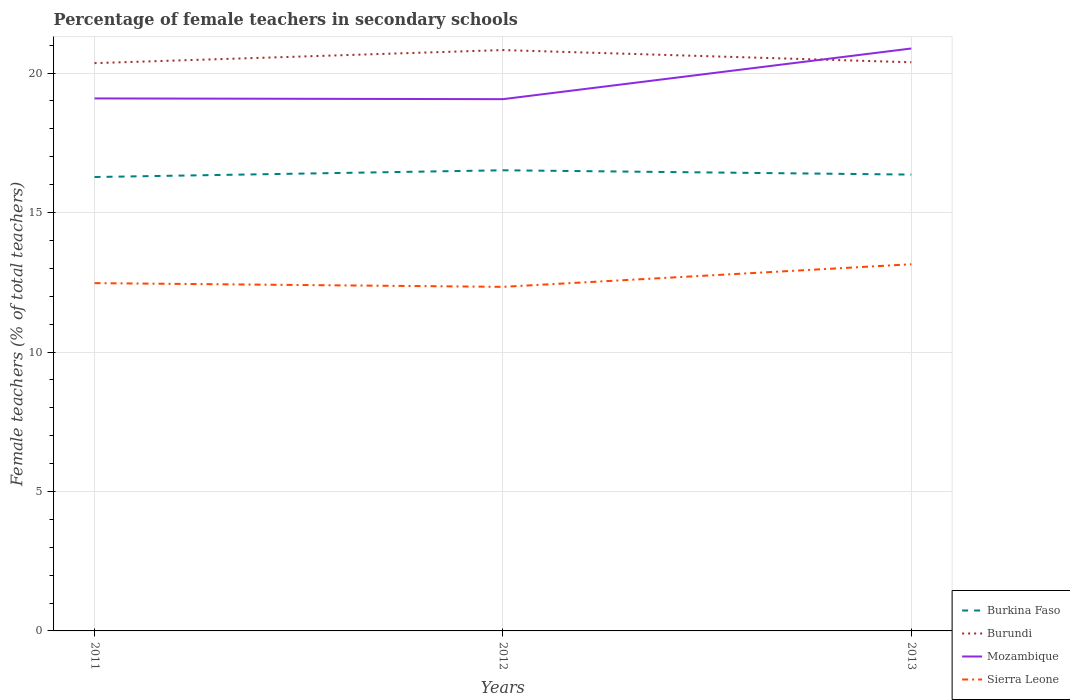How many different coloured lines are there?
Offer a very short reply. 4. Across all years, what is the maximum percentage of female teachers in Burundi?
Provide a succinct answer. 20.36. What is the total percentage of female teachers in Mozambique in the graph?
Offer a terse response. 0.03. What is the difference between the highest and the second highest percentage of female teachers in Sierra Leone?
Your answer should be compact. 0.81. Is the percentage of female teachers in Burkina Faso strictly greater than the percentage of female teachers in Sierra Leone over the years?
Keep it short and to the point. No. What is the difference between two consecutive major ticks on the Y-axis?
Your answer should be compact. 5. Are the values on the major ticks of Y-axis written in scientific E-notation?
Your answer should be compact. No. Does the graph contain any zero values?
Provide a short and direct response. No. What is the title of the graph?
Ensure brevity in your answer.  Percentage of female teachers in secondary schools. What is the label or title of the X-axis?
Offer a very short reply. Years. What is the label or title of the Y-axis?
Offer a very short reply. Female teachers (% of total teachers). What is the Female teachers (% of total teachers) of Burkina Faso in 2011?
Your response must be concise. 16.27. What is the Female teachers (% of total teachers) of Burundi in 2011?
Offer a very short reply. 20.36. What is the Female teachers (% of total teachers) in Mozambique in 2011?
Offer a terse response. 19.09. What is the Female teachers (% of total teachers) in Sierra Leone in 2011?
Offer a very short reply. 12.47. What is the Female teachers (% of total teachers) in Burkina Faso in 2012?
Provide a short and direct response. 16.52. What is the Female teachers (% of total teachers) in Burundi in 2012?
Offer a very short reply. 20.83. What is the Female teachers (% of total teachers) in Mozambique in 2012?
Keep it short and to the point. 19.07. What is the Female teachers (% of total teachers) of Sierra Leone in 2012?
Provide a succinct answer. 12.34. What is the Female teachers (% of total teachers) of Burkina Faso in 2013?
Your answer should be very brief. 16.36. What is the Female teachers (% of total teachers) in Burundi in 2013?
Give a very brief answer. 20.39. What is the Female teachers (% of total teachers) in Mozambique in 2013?
Ensure brevity in your answer.  20.88. What is the Female teachers (% of total teachers) of Sierra Leone in 2013?
Make the answer very short. 13.15. Across all years, what is the maximum Female teachers (% of total teachers) of Burkina Faso?
Provide a short and direct response. 16.52. Across all years, what is the maximum Female teachers (% of total teachers) in Burundi?
Your response must be concise. 20.83. Across all years, what is the maximum Female teachers (% of total teachers) of Mozambique?
Your answer should be compact. 20.88. Across all years, what is the maximum Female teachers (% of total teachers) of Sierra Leone?
Make the answer very short. 13.15. Across all years, what is the minimum Female teachers (% of total teachers) of Burkina Faso?
Your answer should be compact. 16.27. Across all years, what is the minimum Female teachers (% of total teachers) of Burundi?
Offer a very short reply. 20.36. Across all years, what is the minimum Female teachers (% of total teachers) in Mozambique?
Your answer should be compact. 19.07. Across all years, what is the minimum Female teachers (% of total teachers) of Sierra Leone?
Offer a terse response. 12.34. What is the total Female teachers (% of total teachers) in Burkina Faso in the graph?
Make the answer very short. 49.15. What is the total Female teachers (% of total teachers) of Burundi in the graph?
Provide a succinct answer. 61.57. What is the total Female teachers (% of total teachers) in Mozambique in the graph?
Make the answer very short. 59.04. What is the total Female teachers (% of total teachers) of Sierra Leone in the graph?
Provide a succinct answer. 37.95. What is the difference between the Female teachers (% of total teachers) of Burkina Faso in 2011 and that in 2012?
Your response must be concise. -0.24. What is the difference between the Female teachers (% of total teachers) of Burundi in 2011 and that in 2012?
Give a very brief answer. -0.47. What is the difference between the Female teachers (% of total teachers) in Mozambique in 2011 and that in 2012?
Ensure brevity in your answer.  0.03. What is the difference between the Female teachers (% of total teachers) in Sierra Leone in 2011 and that in 2012?
Make the answer very short. 0.13. What is the difference between the Female teachers (% of total teachers) in Burkina Faso in 2011 and that in 2013?
Provide a succinct answer. -0.09. What is the difference between the Female teachers (% of total teachers) in Burundi in 2011 and that in 2013?
Your answer should be compact. -0.03. What is the difference between the Female teachers (% of total teachers) in Mozambique in 2011 and that in 2013?
Provide a short and direct response. -1.79. What is the difference between the Female teachers (% of total teachers) in Sierra Leone in 2011 and that in 2013?
Your response must be concise. -0.68. What is the difference between the Female teachers (% of total teachers) of Burkina Faso in 2012 and that in 2013?
Your answer should be very brief. 0.15. What is the difference between the Female teachers (% of total teachers) of Burundi in 2012 and that in 2013?
Provide a succinct answer. 0.44. What is the difference between the Female teachers (% of total teachers) of Mozambique in 2012 and that in 2013?
Give a very brief answer. -1.82. What is the difference between the Female teachers (% of total teachers) of Sierra Leone in 2012 and that in 2013?
Offer a very short reply. -0.81. What is the difference between the Female teachers (% of total teachers) in Burkina Faso in 2011 and the Female teachers (% of total teachers) in Burundi in 2012?
Your answer should be very brief. -4.55. What is the difference between the Female teachers (% of total teachers) of Burkina Faso in 2011 and the Female teachers (% of total teachers) of Mozambique in 2012?
Ensure brevity in your answer.  -2.79. What is the difference between the Female teachers (% of total teachers) of Burkina Faso in 2011 and the Female teachers (% of total teachers) of Sierra Leone in 2012?
Make the answer very short. 3.94. What is the difference between the Female teachers (% of total teachers) of Burundi in 2011 and the Female teachers (% of total teachers) of Mozambique in 2012?
Provide a succinct answer. 1.29. What is the difference between the Female teachers (% of total teachers) of Burundi in 2011 and the Female teachers (% of total teachers) of Sierra Leone in 2012?
Your answer should be very brief. 8.02. What is the difference between the Female teachers (% of total teachers) of Mozambique in 2011 and the Female teachers (% of total teachers) of Sierra Leone in 2012?
Ensure brevity in your answer.  6.76. What is the difference between the Female teachers (% of total teachers) in Burkina Faso in 2011 and the Female teachers (% of total teachers) in Burundi in 2013?
Your answer should be compact. -4.11. What is the difference between the Female teachers (% of total teachers) in Burkina Faso in 2011 and the Female teachers (% of total teachers) in Mozambique in 2013?
Your answer should be compact. -4.61. What is the difference between the Female teachers (% of total teachers) in Burkina Faso in 2011 and the Female teachers (% of total teachers) in Sierra Leone in 2013?
Provide a succinct answer. 3.13. What is the difference between the Female teachers (% of total teachers) in Burundi in 2011 and the Female teachers (% of total teachers) in Mozambique in 2013?
Your answer should be compact. -0.52. What is the difference between the Female teachers (% of total teachers) in Burundi in 2011 and the Female teachers (% of total teachers) in Sierra Leone in 2013?
Give a very brief answer. 7.21. What is the difference between the Female teachers (% of total teachers) in Mozambique in 2011 and the Female teachers (% of total teachers) in Sierra Leone in 2013?
Offer a terse response. 5.95. What is the difference between the Female teachers (% of total teachers) in Burkina Faso in 2012 and the Female teachers (% of total teachers) in Burundi in 2013?
Ensure brevity in your answer.  -3.87. What is the difference between the Female teachers (% of total teachers) in Burkina Faso in 2012 and the Female teachers (% of total teachers) in Mozambique in 2013?
Your answer should be very brief. -4.37. What is the difference between the Female teachers (% of total teachers) of Burkina Faso in 2012 and the Female teachers (% of total teachers) of Sierra Leone in 2013?
Provide a short and direct response. 3.37. What is the difference between the Female teachers (% of total teachers) of Burundi in 2012 and the Female teachers (% of total teachers) of Mozambique in 2013?
Your response must be concise. -0.06. What is the difference between the Female teachers (% of total teachers) of Burundi in 2012 and the Female teachers (% of total teachers) of Sierra Leone in 2013?
Offer a very short reply. 7.68. What is the difference between the Female teachers (% of total teachers) in Mozambique in 2012 and the Female teachers (% of total teachers) in Sierra Leone in 2013?
Your response must be concise. 5.92. What is the average Female teachers (% of total teachers) in Burkina Faso per year?
Offer a very short reply. 16.38. What is the average Female teachers (% of total teachers) in Burundi per year?
Ensure brevity in your answer.  20.52. What is the average Female teachers (% of total teachers) in Mozambique per year?
Your answer should be very brief. 19.68. What is the average Female teachers (% of total teachers) of Sierra Leone per year?
Offer a terse response. 12.65. In the year 2011, what is the difference between the Female teachers (% of total teachers) of Burkina Faso and Female teachers (% of total teachers) of Burundi?
Offer a very short reply. -4.08. In the year 2011, what is the difference between the Female teachers (% of total teachers) in Burkina Faso and Female teachers (% of total teachers) in Mozambique?
Provide a succinct answer. -2.82. In the year 2011, what is the difference between the Female teachers (% of total teachers) of Burkina Faso and Female teachers (% of total teachers) of Sierra Leone?
Ensure brevity in your answer.  3.8. In the year 2011, what is the difference between the Female teachers (% of total teachers) of Burundi and Female teachers (% of total teachers) of Mozambique?
Provide a short and direct response. 1.27. In the year 2011, what is the difference between the Female teachers (% of total teachers) in Burundi and Female teachers (% of total teachers) in Sierra Leone?
Keep it short and to the point. 7.89. In the year 2011, what is the difference between the Female teachers (% of total teachers) of Mozambique and Female teachers (% of total teachers) of Sierra Leone?
Give a very brief answer. 6.62. In the year 2012, what is the difference between the Female teachers (% of total teachers) in Burkina Faso and Female teachers (% of total teachers) in Burundi?
Your response must be concise. -4.31. In the year 2012, what is the difference between the Female teachers (% of total teachers) in Burkina Faso and Female teachers (% of total teachers) in Mozambique?
Ensure brevity in your answer.  -2.55. In the year 2012, what is the difference between the Female teachers (% of total teachers) of Burkina Faso and Female teachers (% of total teachers) of Sierra Leone?
Your response must be concise. 4.18. In the year 2012, what is the difference between the Female teachers (% of total teachers) of Burundi and Female teachers (% of total teachers) of Mozambique?
Give a very brief answer. 1.76. In the year 2012, what is the difference between the Female teachers (% of total teachers) in Burundi and Female teachers (% of total teachers) in Sierra Leone?
Your answer should be very brief. 8.49. In the year 2012, what is the difference between the Female teachers (% of total teachers) of Mozambique and Female teachers (% of total teachers) of Sierra Leone?
Offer a very short reply. 6.73. In the year 2013, what is the difference between the Female teachers (% of total teachers) in Burkina Faso and Female teachers (% of total teachers) in Burundi?
Offer a very short reply. -4.03. In the year 2013, what is the difference between the Female teachers (% of total teachers) of Burkina Faso and Female teachers (% of total teachers) of Mozambique?
Offer a terse response. -4.52. In the year 2013, what is the difference between the Female teachers (% of total teachers) of Burkina Faso and Female teachers (% of total teachers) of Sierra Leone?
Your answer should be compact. 3.22. In the year 2013, what is the difference between the Female teachers (% of total teachers) in Burundi and Female teachers (% of total teachers) in Mozambique?
Give a very brief answer. -0.49. In the year 2013, what is the difference between the Female teachers (% of total teachers) in Burundi and Female teachers (% of total teachers) in Sierra Leone?
Keep it short and to the point. 7.24. In the year 2013, what is the difference between the Female teachers (% of total teachers) in Mozambique and Female teachers (% of total teachers) in Sierra Leone?
Ensure brevity in your answer.  7.74. What is the ratio of the Female teachers (% of total teachers) in Burkina Faso in 2011 to that in 2012?
Provide a succinct answer. 0.99. What is the ratio of the Female teachers (% of total teachers) in Burundi in 2011 to that in 2012?
Give a very brief answer. 0.98. What is the ratio of the Female teachers (% of total teachers) of Mozambique in 2011 to that in 2012?
Keep it short and to the point. 1. What is the ratio of the Female teachers (% of total teachers) of Sierra Leone in 2011 to that in 2012?
Give a very brief answer. 1.01. What is the ratio of the Female teachers (% of total teachers) in Burkina Faso in 2011 to that in 2013?
Give a very brief answer. 0.99. What is the ratio of the Female teachers (% of total teachers) of Burundi in 2011 to that in 2013?
Provide a succinct answer. 1. What is the ratio of the Female teachers (% of total teachers) of Mozambique in 2011 to that in 2013?
Keep it short and to the point. 0.91. What is the ratio of the Female teachers (% of total teachers) in Sierra Leone in 2011 to that in 2013?
Your answer should be very brief. 0.95. What is the ratio of the Female teachers (% of total teachers) of Burkina Faso in 2012 to that in 2013?
Your answer should be compact. 1.01. What is the ratio of the Female teachers (% of total teachers) in Burundi in 2012 to that in 2013?
Ensure brevity in your answer.  1.02. What is the ratio of the Female teachers (% of total teachers) of Sierra Leone in 2012 to that in 2013?
Provide a succinct answer. 0.94. What is the difference between the highest and the second highest Female teachers (% of total teachers) of Burkina Faso?
Ensure brevity in your answer.  0.15. What is the difference between the highest and the second highest Female teachers (% of total teachers) in Burundi?
Provide a short and direct response. 0.44. What is the difference between the highest and the second highest Female teachers (% of total teachers) of Mozambique?
Offer a terse response. 1.79. What is the difference between the highest and the second highest Female teachers (% of total teachers) in Sierra Leone?
Provide a short and direct response. 0.68. What is the difference between the highest and the lowest Female teachers (% of total teachers) in Burkina Faso?
Your answer should be compact. 0.24. What is the difference between the highest and the lowest Female teachers (% of total teachers) of Burundi?
Offer a very short reply. 0.47. What is the difference between the highest and the lowest Female teachers (% of total teachers) in Mozambique?
Your response must be concise. 1.82. What is the difference between the highest and the lowest Female teachers (% of total teachers) in Sierra Leone?
Make the answer very short. 0.81. 